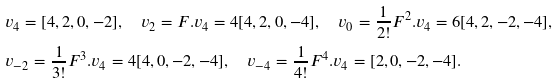Convert formula to latex. <formula><loc_0><loc_0><loc_500><loc_500>& v _ { 4 } = [ 4 , 2 , 0 , - 2 ] , \quad v _ { 2 } = F . v _ { 4 } = 4 [ 4 , 2 , 0 , - 4 ] , \quad v _ { 0 } = \frac { 1 } { 2 ! } F ^ { 2 } . v _ { 4 } = 6 [ 4 , 2 , - 2 , - 4 ] , \\ & v _ { - 2 } = \frac { 1 } { 3 ! } F ^ { 3 } . v _ { 4 } = 4 [ 4 , 0 , - 2 , - 4 ] , \quad v _ { - 4 } = \frac { 1 } { 4 ! } F ^ { 4 } . v _ { 4 } = [ 2 , 0 , - 2 , - 4 ] .</formula> 